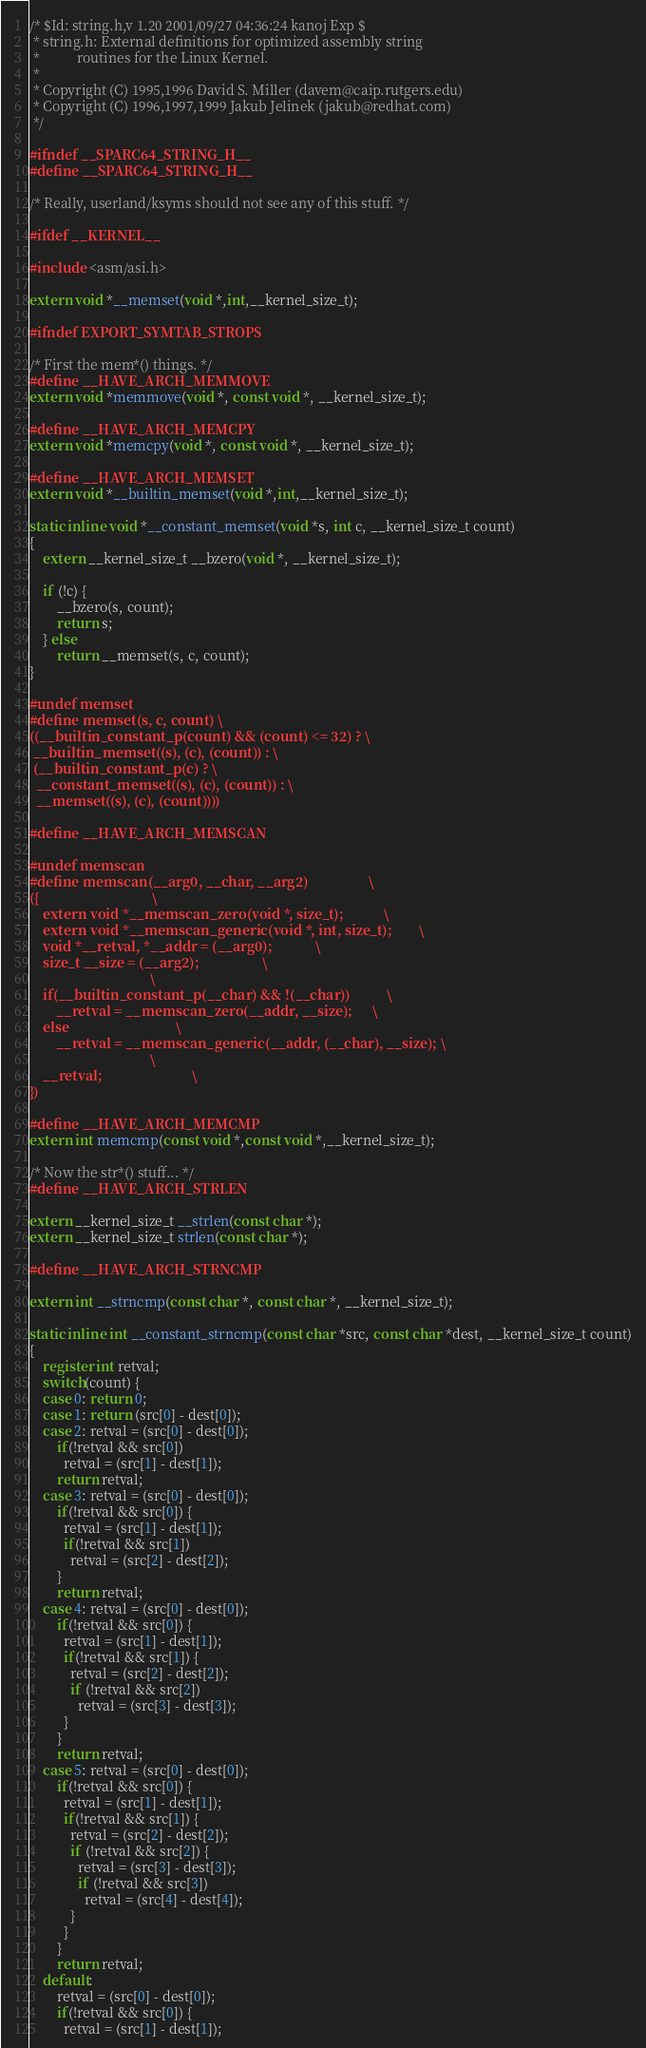<code> <loc_0><loc_0><loc_500><loc_500><_C_>/* $Id: string.h,v 1.20 2001/09/27 04:36:24 kanoj Exp $
 * string.h: External definitions for optimized assembly string
 *           routines for the Linux Kernel.
 *
 * Copyright (C) 1995,1996 David S. Miller (davem@caip.rutgers.edu)
 * Copyright (C) 1996,1997,1999 Jakub Jelinek (jakub@redhat.com)
 */

#ifndef __SPARC64_STRING_H__
#define __SPARC64_STRING_H__

/* Really, userland/ksyms should not see any of this stuff. */

#ifdef __KERNEL__

#include <asm/asi.h>

extern void *__memset(void *,int,__kernel_size_t);

#ifndef EXPORT_SYMTAB_STROPS

/* First the mem*() things. */
#define __HAVE_ARCH_MEMMOVE
extern void *memmove(void *, const void *, __kernel_size_t);

#define __HAVE_ARCH_MEMCPY
extern void *memcpy(void *, const void *, __kernel_size_t);

#define __HAVE_ARCH_MEMSET
extern void *__builtin_memset(void *,int,__kernel_size_t);

static inline void *__constant_memset(void *s, int c, __kernel_size_t count)
{
	extern __kernel_size_t __bzero(void *, __kernel_size_t);

	if (!c) {
		__bzero(s, count);
		return s;
	} else
		return __memset(s, c, count);
}

#undef memset
#define memset(s, c, count) \
((__builtin_constant_p(count) && (count) <= 32) ? \
 __builtin_memset((s), (c), (count)) : \
 (__builtin_constant_p(c) ? \
  __constant_memset((s), (c), (count)) : \
  __memset((s), (c), (count))))

#define __HAVE_ARCH_MEMSCAN

#undef memscan
#define memscan(__arg0, __char, __arg2)					\
({									\
	extern void *__memscan_zero(void *, size_t);			\
	extern void *__memscan_generic(void *, int, size_t);		\
	void *__retval, *__addr = (__arg0);				\
	size_t __size = (__arg2);					\
									\
	if(__builtin_constant_p(__char) && !(__char))			\
		__retval = __memscan_zero(__addr, __size);		\
	else								\
		__retval = __memscan_generic(__addr, (__char), __size);	\
									\
	__retval;							\
})

#define __HAVE_ARCH_MEMCMP
extern int memcmp(const void *,const void *,__kernel_size_t);

/* Now the str*() stuff... */
#define __HAVE_ARCH_STRLEN

extern __kernel_size_t __strlen(const char *);
extern __kernel_size_t strlen(const char *);

#define __HAVE_ARCH_STRNCMP

extern int __strncmp(const char *, const char *, __kernel_size_t);

static inline int __constant_strncmp(const char *src, const char *dest, __kernel_size_t count)
{
	register int retval;
	switch(count) {
	case 0: return 0;
	case 1: return (src[0] - dest[0]);
	case 2: retval = (src[0] - dest[0]);
		if(!retval && src[0])
		  retval = (src[1] - dest[1]);
		return retval;
	case 3: retval = (src[0] - dest[0]);
		if(!retval && src[0]) {
		  retval = (src[1] - dest[1]);
		  if(!retval && src[1])
		    retval = (src[2] - dest[2]);
		}
		return retval;
	case 4: retval = (src[0] - dest[0]);
		if(!retval && src[0]) {
		  retval = (src[1] - dest[1]);
		  if(!retval && src[1]) {
		    retval = (src[2] - dest[2]);
		    if (!retval && src[2])
		      retval = (src[3] - dest[3]);
		  }
		}
		return retval;
	case 5: retval = (src[0] - dest[0]);
		if(!retval && src[0]) {
		  retval = (src[1] - dest[1]);
		  if(!retval && src[1]) {
		    retval = (src[2] - dest[2]);
		    if (!retval && src[2]) {
		      retval = (src[3] - dest[3]);
		      if (!retval && src[3])
		        retval = (src[4] - dest[4]);
		    }
		  }
		}
		return retval;
	default:
		retval = (src[0] - dest[0]);
		if(!retval && src[0]) {
		  retval = (src[1] - dest[1]);</code> 